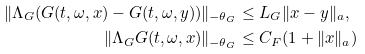Convert formula to latex. <formula><loc_0><loc_0><loc_500><loc_500>\| \Lambda _ { G } ( G ( t , \omega , x ) - G ( t , \omega , y ) ) \| _ { - \theta _ { G } } & \leq L _ { G } \| x - y \| _ { a } , \\ \| \Lambda _ { G } G ( t , \omega , x ) \| _ { - \theta _ { G } } & \leq C _ { F } ( 1 + \| x \| _ { a } )</formula> 